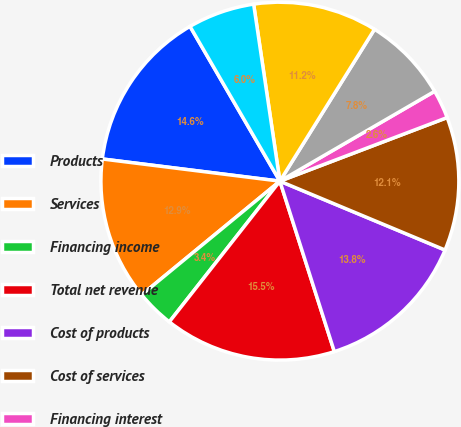Convert chart to OTSL. <chart><loc_0><loc_0><loc_500><loc_500><pie_chart><fcel>Products<fcel>Services<fcel>Financing income<fcel>Total net revenue<fcel>Cost of products<fcel>Cost of services<fcel>Financing interest<fcel>Research and development<fcel>Selling general and<fcel>Amortization of purchased<nl><fcel>14.65%<fcel>12.93%<fcel>3.45%<fcel>15.52%<fcel>13.79%<fcel>12.07%<fcel>2.59%<fcel>7.76%<fcel>11.21%<fcel>6.03%<nl></chart> 